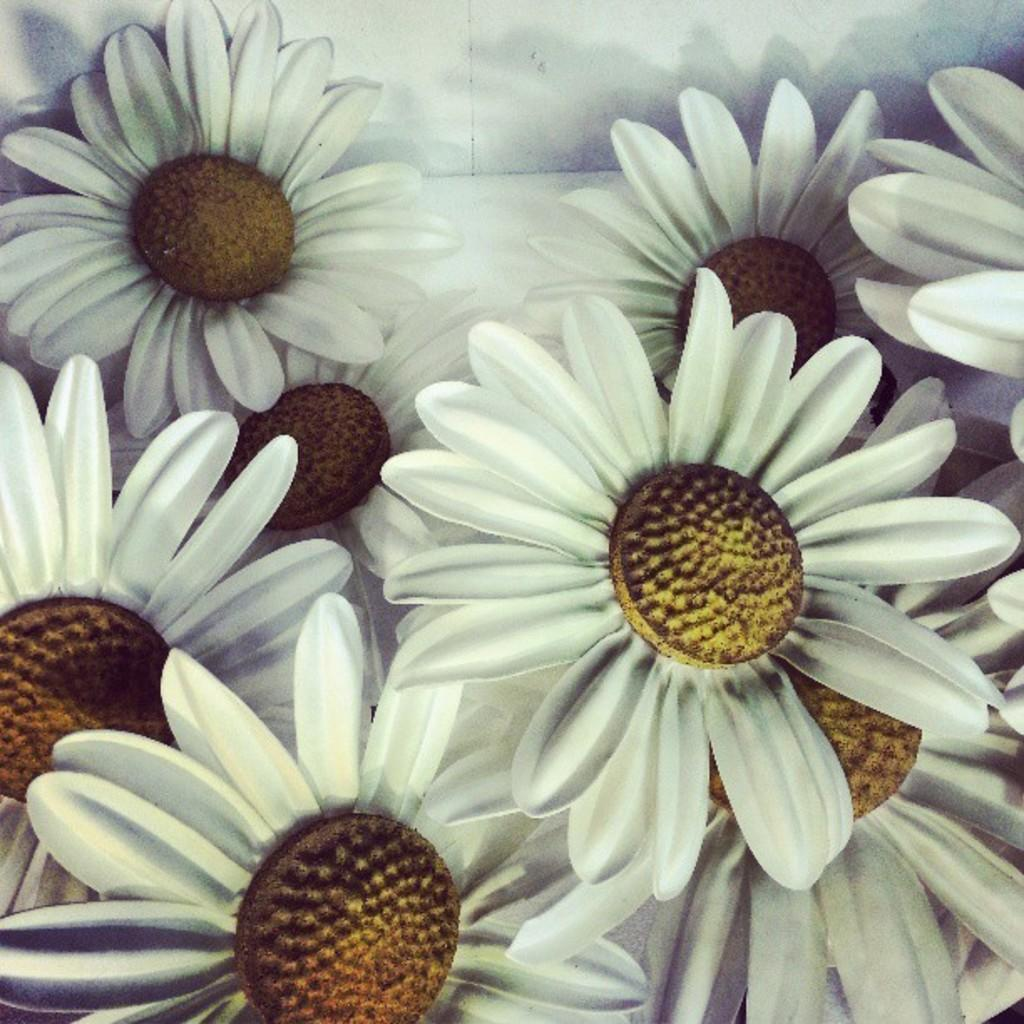What type of flowers are in the image? There are artificial flowers in the image. Where are the flowers placed in the image? The flowers are kept on the floor. What color are the flowers in the image? The flowers are white in color. What grade did the flowers receive for their performance in the image? There is no performance or grade associated with the flowers in the image, as they are artificial flowers placed on the floor. 